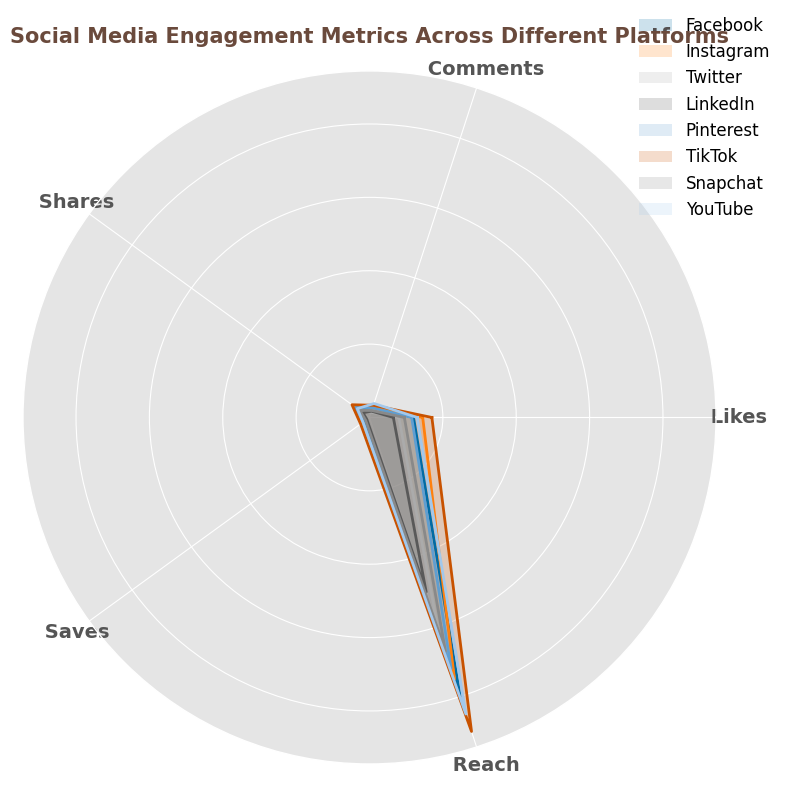What platform has the highest number of likes? Observing the radar chart, TikTok has the largest area in the 'Likes' axis which indicates it has the highest number.
Answer: TikTok Which platform has higher reach, Facebook or Instagram? Comparing their positions along the 'Reach' axis, Facebook is slightly higher than Instagram.
Answer: Facebook What is the total number of comments on TikTok and LinkedIn combined? Summing the 'Comments' values for TikTok (350) and LinkedIn (180) we get 350 + 180 = 530.
Answer: 530 Among Instagram, Pinterest, and YouTube, which platform has the lowest shares? The 'Shares' axis shows that YouTube has a smaller value in comparison to Instagram and Pinterest.
Answer: YouTube Which platform exhibits a better engagement rate, Twitter or Snapchat? On the radar chart, comparing the values for 'EngagementRate', Snapchat lies on a higher radial distance than Twitter.
Answer: Snapchat Identify the platform with the smallest value for saves. Observing the 'Saves' axis, LinkedIn has the lowest values.
Answer: LinkedIn What is the difference in the number of shares between TikTok and Facebook? TikTok has 590 shares and Facebook has 450 shares, the difference is 590 - 450 = 140.
Answer: 140 Which platform has a more balanced distribution of engagement metrics across all categories? By observing the polygons, Instagram's shape is the most uniform around the central point across all axes.
Answer: Instagram Calculate the average reach of Facebook, Instagram, and Twitter. Adding their respective 'Reach' values: 8000 (Facebook) + 7500 (Instagram) + 6000 (Twitter) = 21500, then, 21500 / 3 = 7166.67.
Answer: 7166.67 What is the ratio of likes between Pinterest and Snapchat? Pinterest has 1150 likes and Snapchat has 950, the ratio is 1150 / 950 ≈ 1.21.
Answer: 1.21 